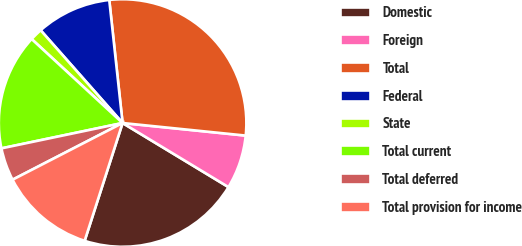<chart> <loc_0><loc_0><loc_500><loc_500><pie_chart><fcel>Domestic<fcel>Foreign<fcel>Total<fcel>Federal<fcel>State<fcel>Total current<fcel>Total deferred<fcel>Total provision for income<nl><fcel>21.3%<fcel>7.04%<fcel>28.34%<fcel>9.8%<fcel>1.62%<fcel>15.15%<fcel>4.29%<fcel>12.47%<nl></chart> 